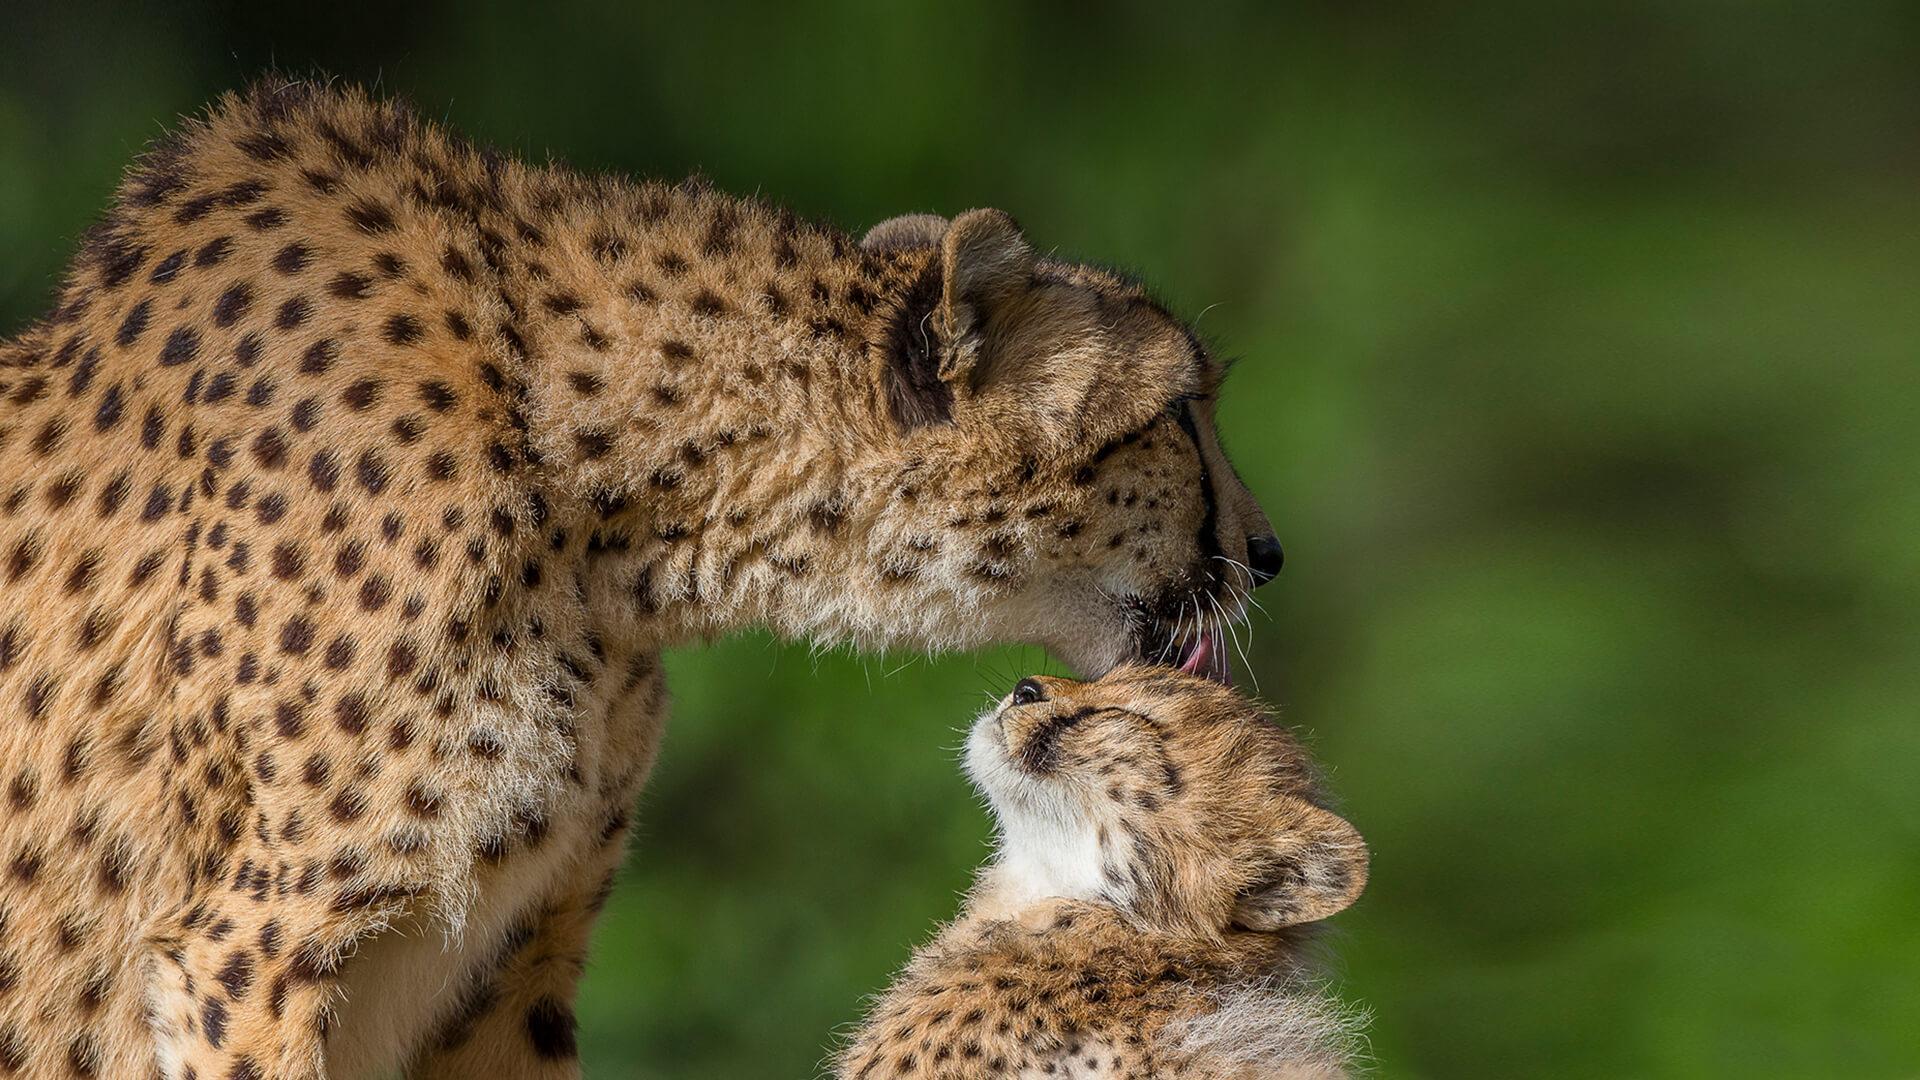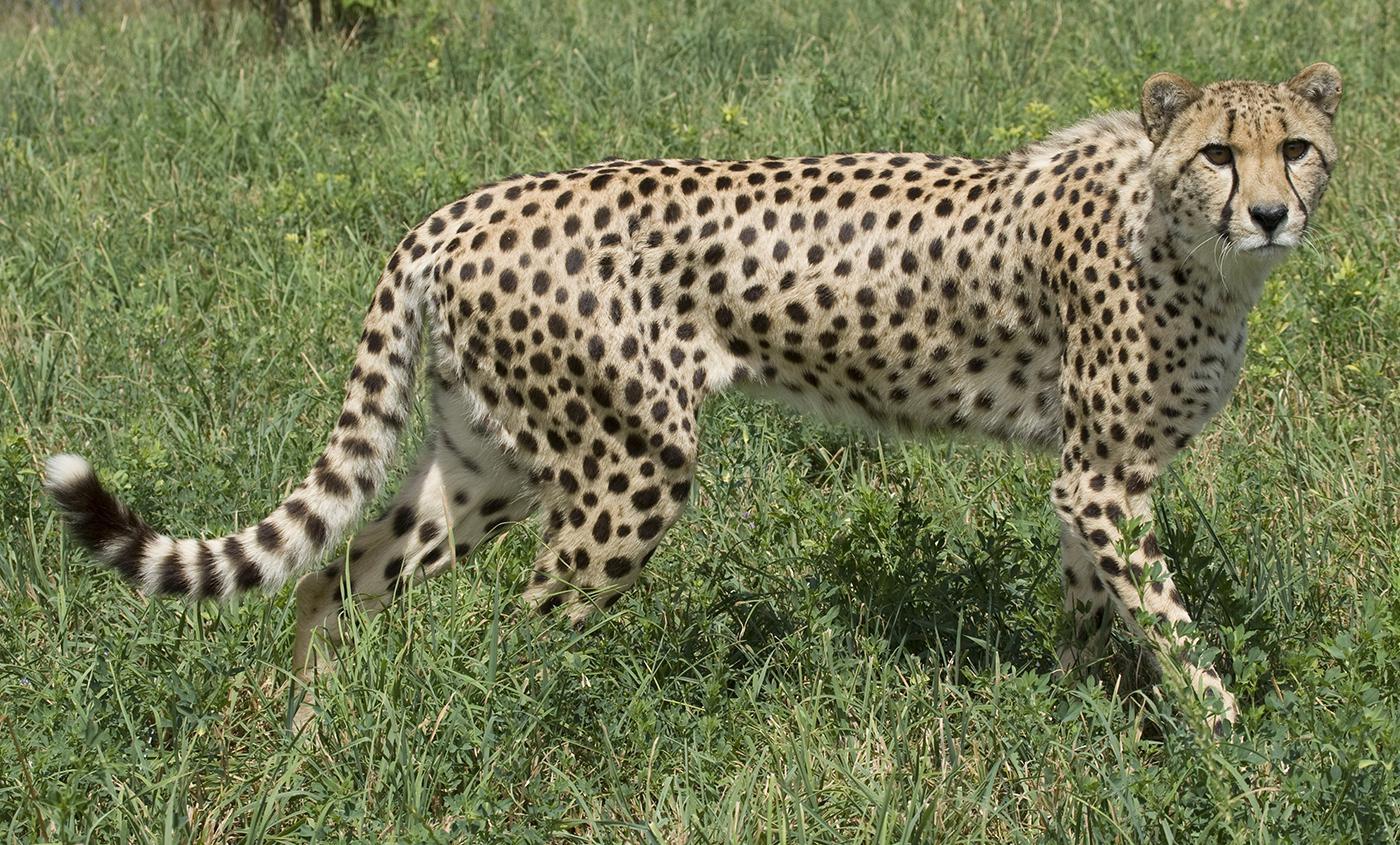The first image is the image on the left, the second image is the image on the right. For the images displayed, is the sentence "A single leopard is lying down in the image on the left." factually correct? Answer yes or no. No. The first image is the image on the left, the second image is the image on the right. For the images displayed, is the sentence "A cheetah is in bounding pose, with its back legs forward, in front of its front legs." factually correct? Answer yes or no. No. 